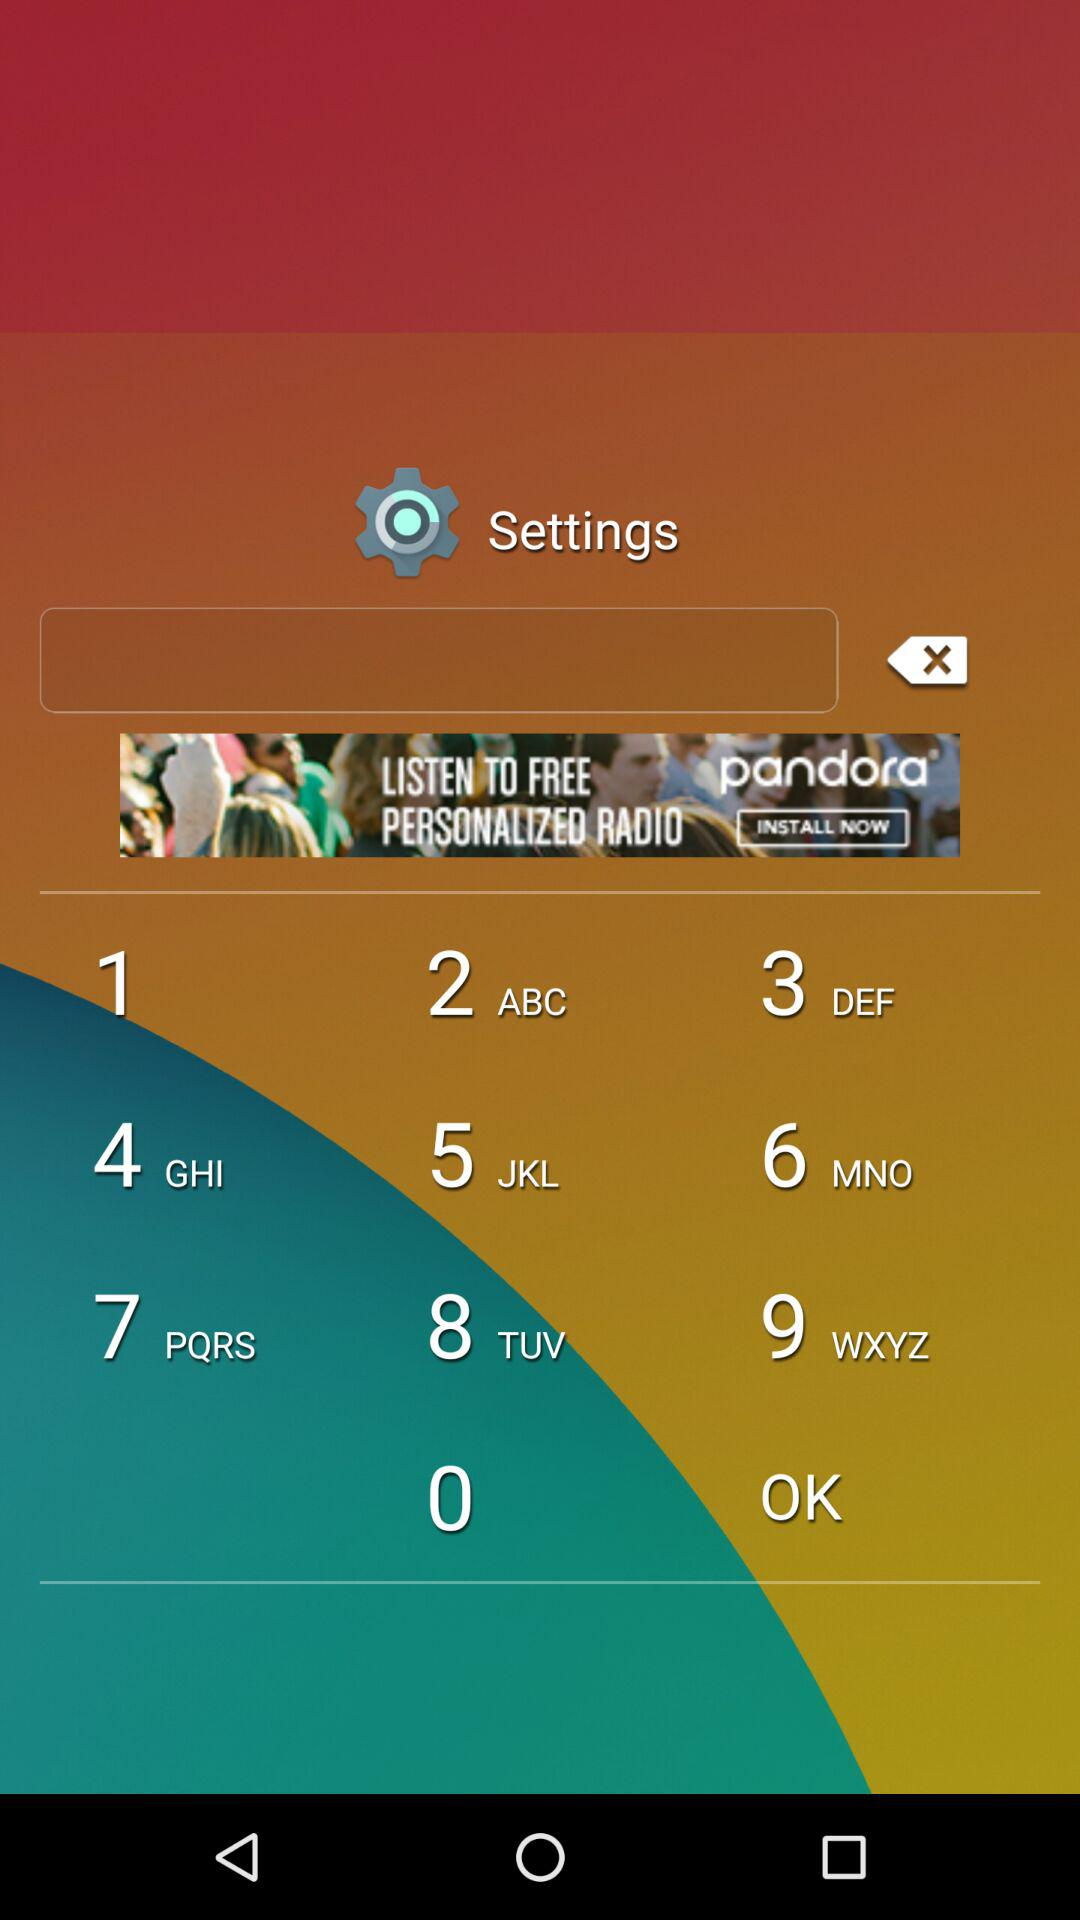Which tests can be measured? The tests that can be measured are "Blood pressure", "Oxygen", "Heart rate", "Psychological", "Lung capacity", "Vision", "Hearing" and "Respiratory rate". 